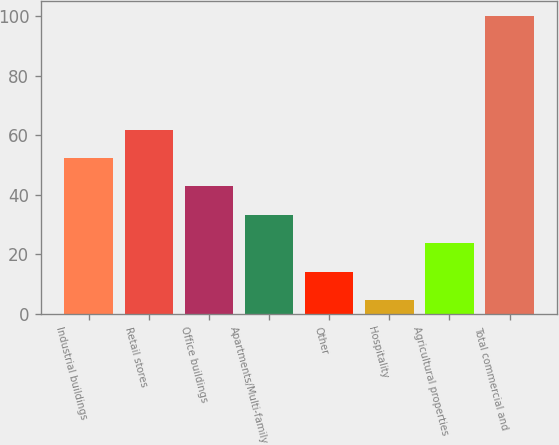<chart> <loc_0><loc_0><loc_500><loc_500><bar_chart><fcel>Industrial buildings<fcel>Retail stores<fcel>Office buildings<fcel>Apartments/Multi-family<fcel>Other<fcel>Hospitality<fcel>Agricultural properties<fcel>Total commercial and<nl><fcel>52.35<fcel>61.88<fcel>42.82<fcel>33.29<fcel>14.23<fcel>4.7<fcel>23.76<fcel>100<nl></chart> 